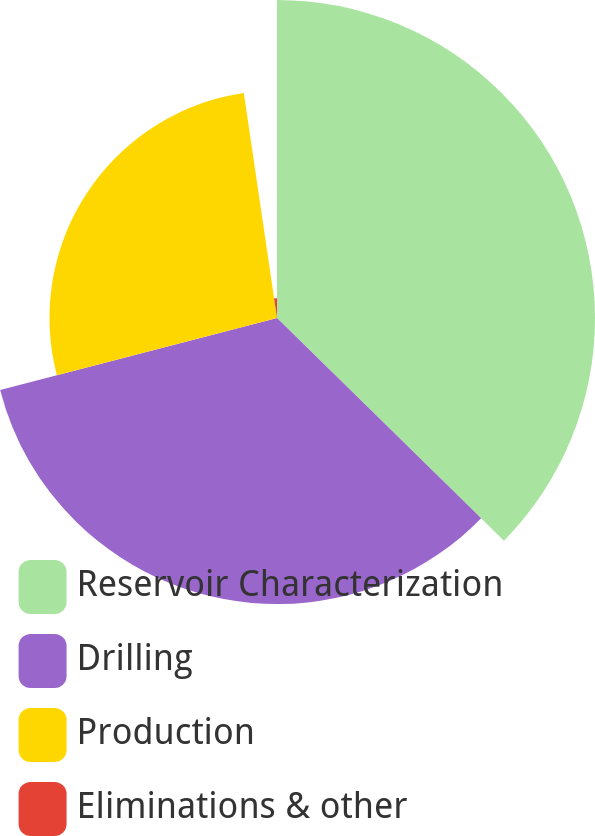<chart> <loc_0><loc_0><loc_500><loc_500><pie_chart><fcel>Reservoir Characterization<fcel>Drilling<fcel>Production<fcel>Eliminations & other<nl><fcel>37.35%<fcel>33.6%<fcel>26.72%<fcel>2.33%<nl></chart> 